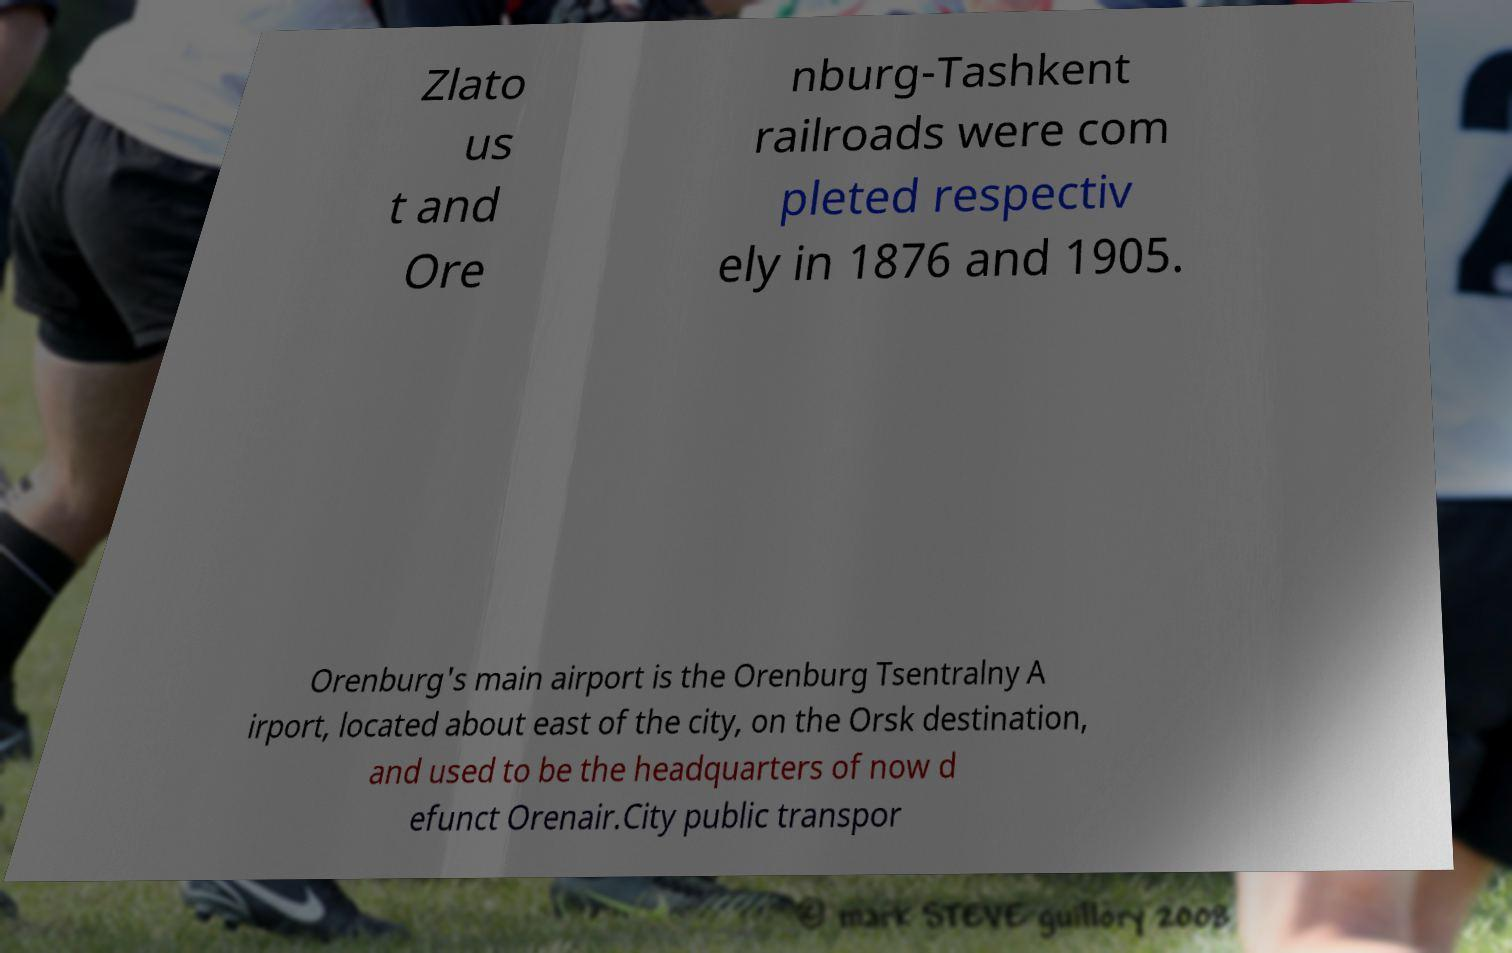Please identify and transcribe the text found in this image. Zlato us t and Ore nburg-Tashkent railroads were com pleted respectiv ely in 1876 and 1905. Orenburg's main airport is the Orenburg Tsentralny A irport, located about east of the city, on the Orsk destination, and used to be the headquarters of now d efunct Orenair.City public transpor 